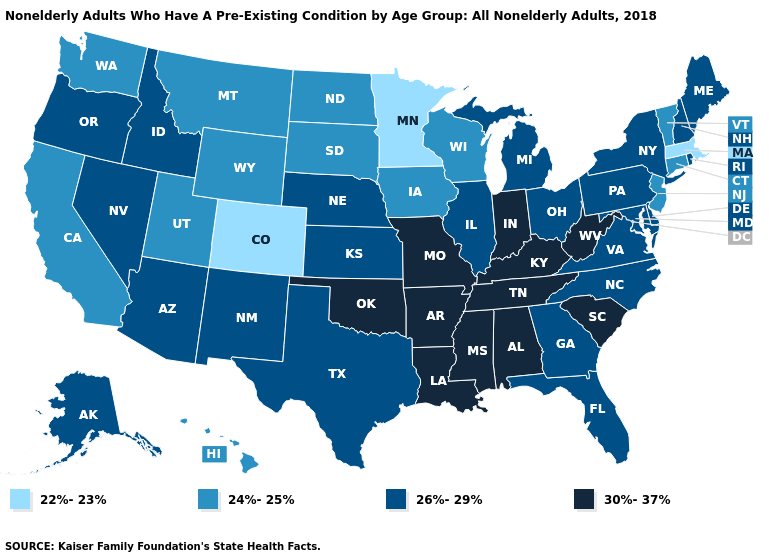What is the value of New Mexico?
Answer briefly. 26%-29%. Name the states that have a value in the range 26%-29%?
Give a very brief answer. Alaska, Arizona, Delaware, Florida, Georgia, Idaho, Illinois, Kansas, Maine, Maryland, Michigan, Nebraska, Nevada, New Hampshire, New Mexico, New York, North Carolina, Ohio, Oregon, Pennsylvania, Rhode Island, Texas, Virginia. Does Wyoming have the highest value in the West?
Short answer required. No. Among the states that border Virginia , does North Carolina have the lowest value?
Give a very brief answer. Yes. What is the value of Tennessee?
Be succinct. 30%-37%. Which states have the lowest value in the MidWest?
Keep it brief. Minnesota. Name the states that have a value in the range 24%-25%?
Answer briefly. California, Connecticut, Hawaii, Iowa, Montana, New Jersey, North Dakota, South Dakota, Utah, Vermont, Washington, Wisconsin, Wyoming. Does Kentucky have a lower value than Missouri?
Give a very brief answer. No. What is the highest value in the USA?
Give a very brief answer. 30%-37%. What is the highest value in the USA?
Give a very brief answer. 30%-37%. What is the highest value in states that border Florida?
Give a very brief answer. 30%-37%. How many symbols are there in the legend?
Quick response, please. 4. Which states have the highest value in the USA?
Keep it brief. Alabama, Arkansas, Indiana, Kentucky, Louisiana, Mississippi, Missouri, Oklahoma, South Carolina, Tennessee, West Virginia. Does North Dakota have a higher value than Colorado?
Be succinct. Yes. Which states have the lowest value in the USA?
Answer briefly. Colorado, Massachusetts, Minnesota. 